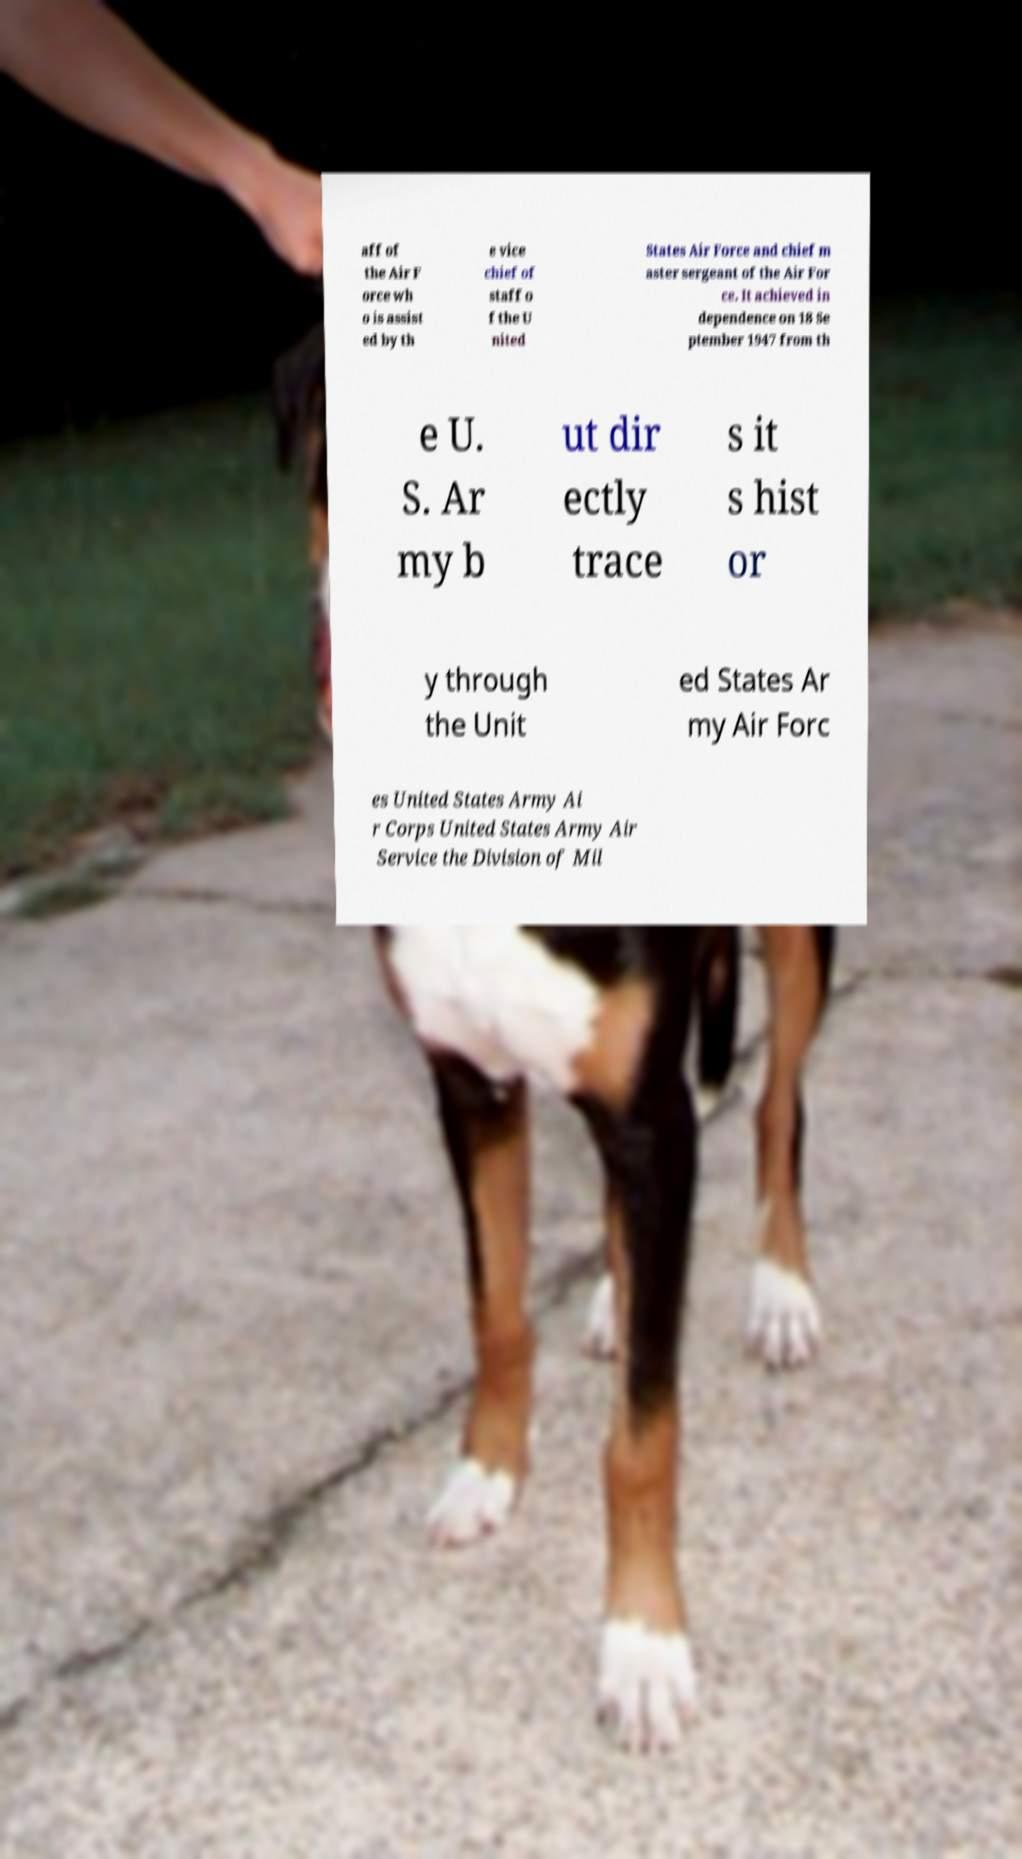Can you accurately transcribe the text from the provided image for me? aff of the Air F orce wh o is assist ed by th e vice chief of staff o f the U nited States Air Force and chief m aster sergeant of the Air For ce. It achieved in dependence on 18 Se ptember 1947 from th e U. S. Ar my b ut dir ectly trace s it s hist or y through the Unit ed States Ar my Air Forc es United States Army Ai r Corps United States Army Air Service the Division of Mil 